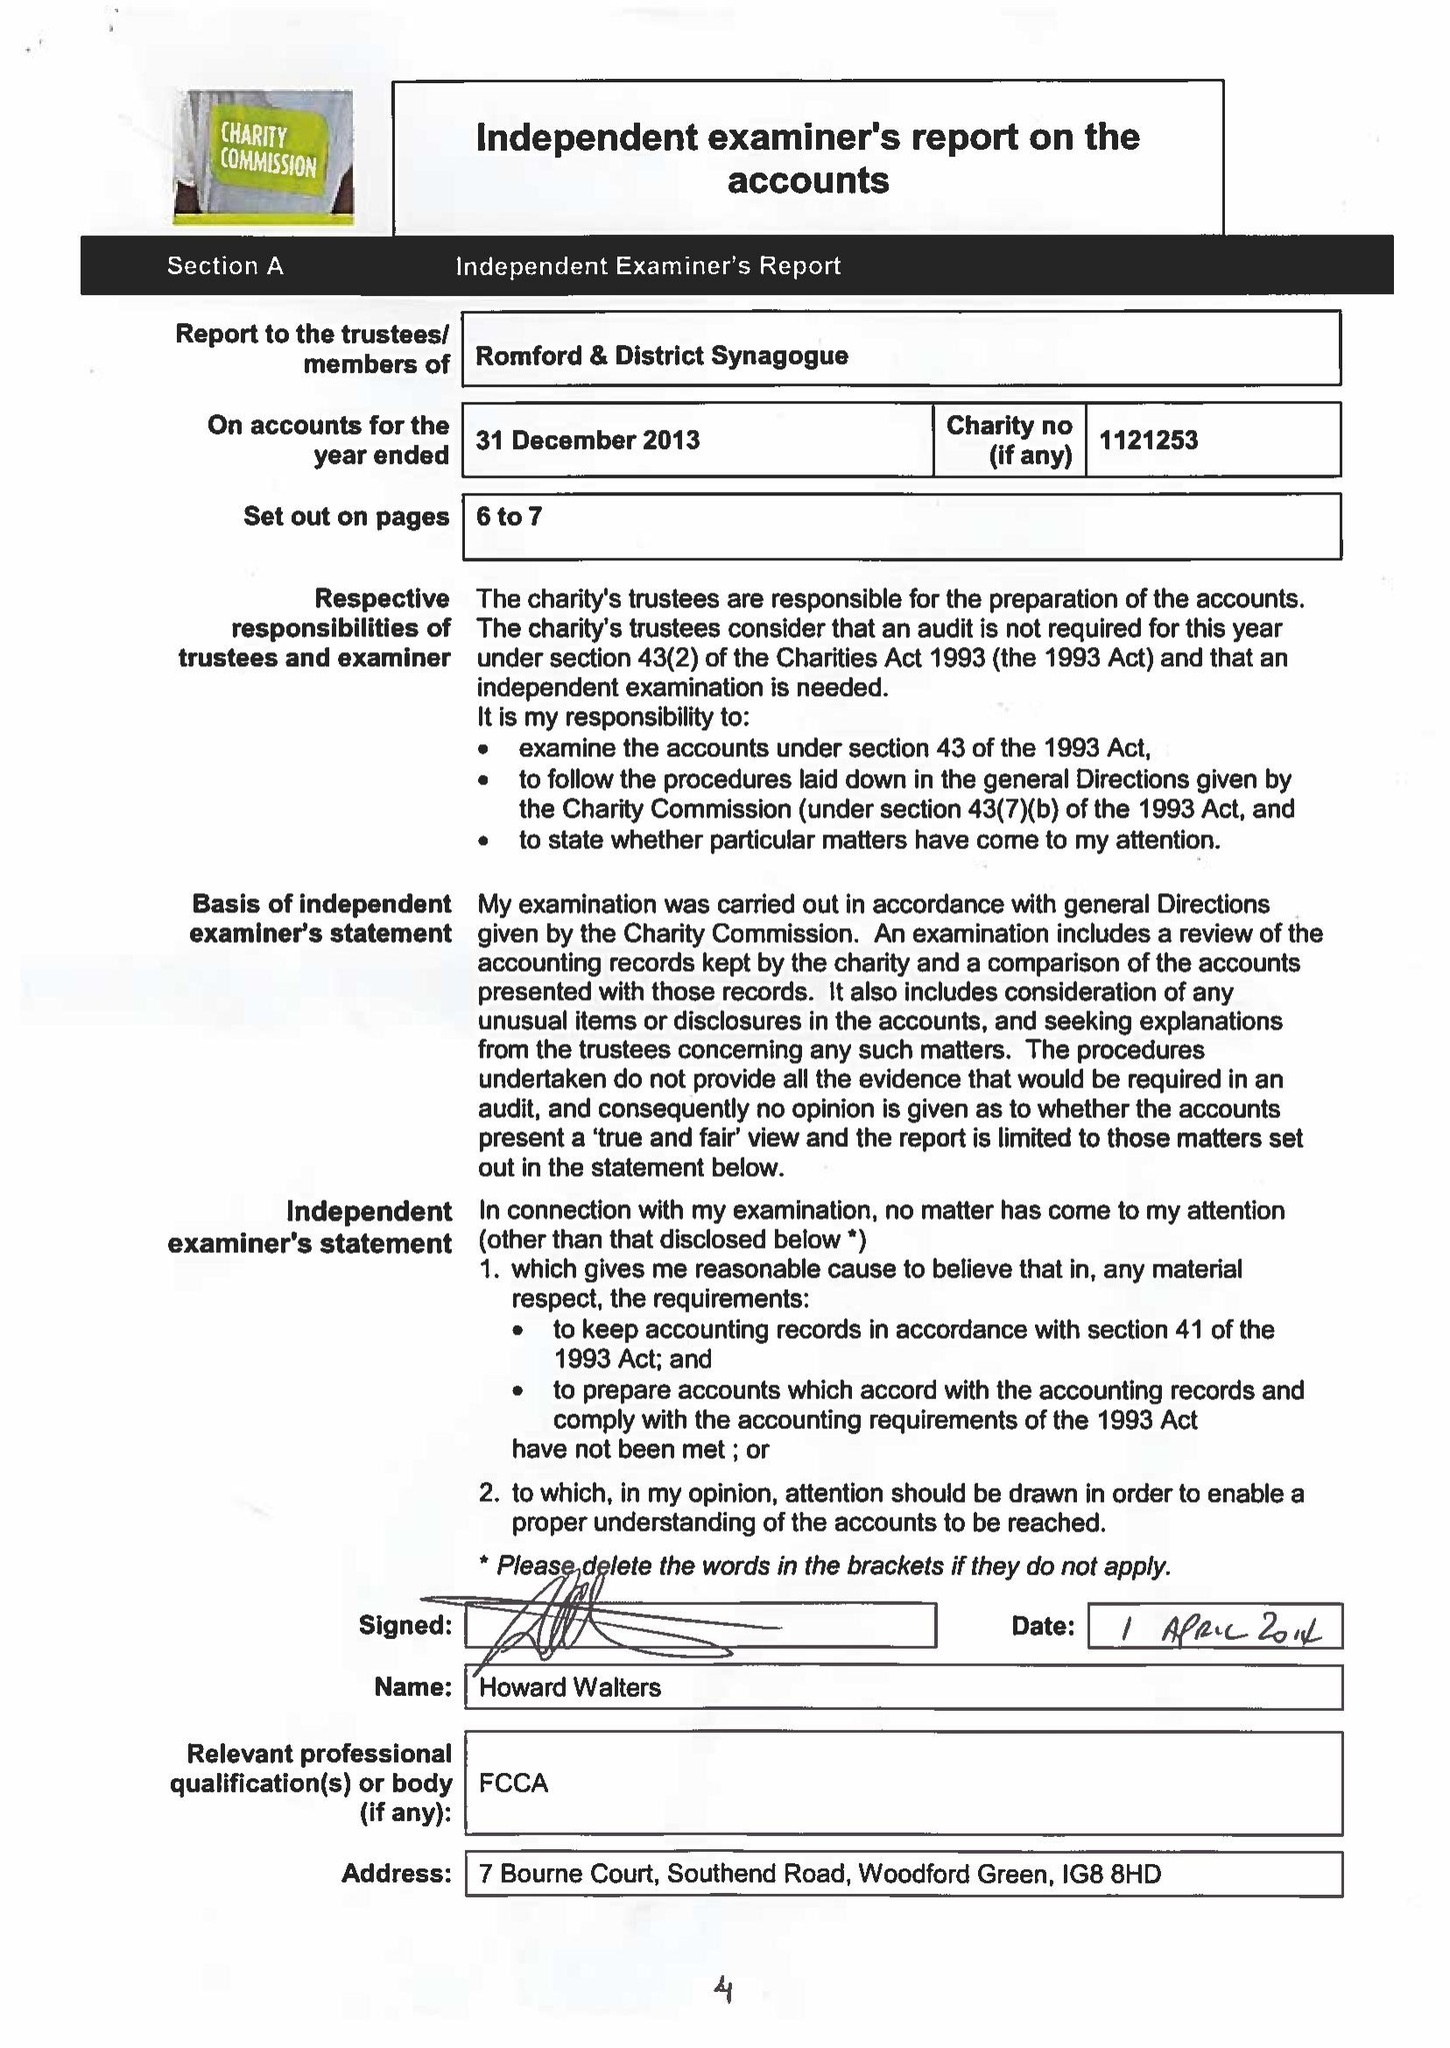What is the value for the report_date?
Answer the question using a single word or phrase. 2013-12-31 